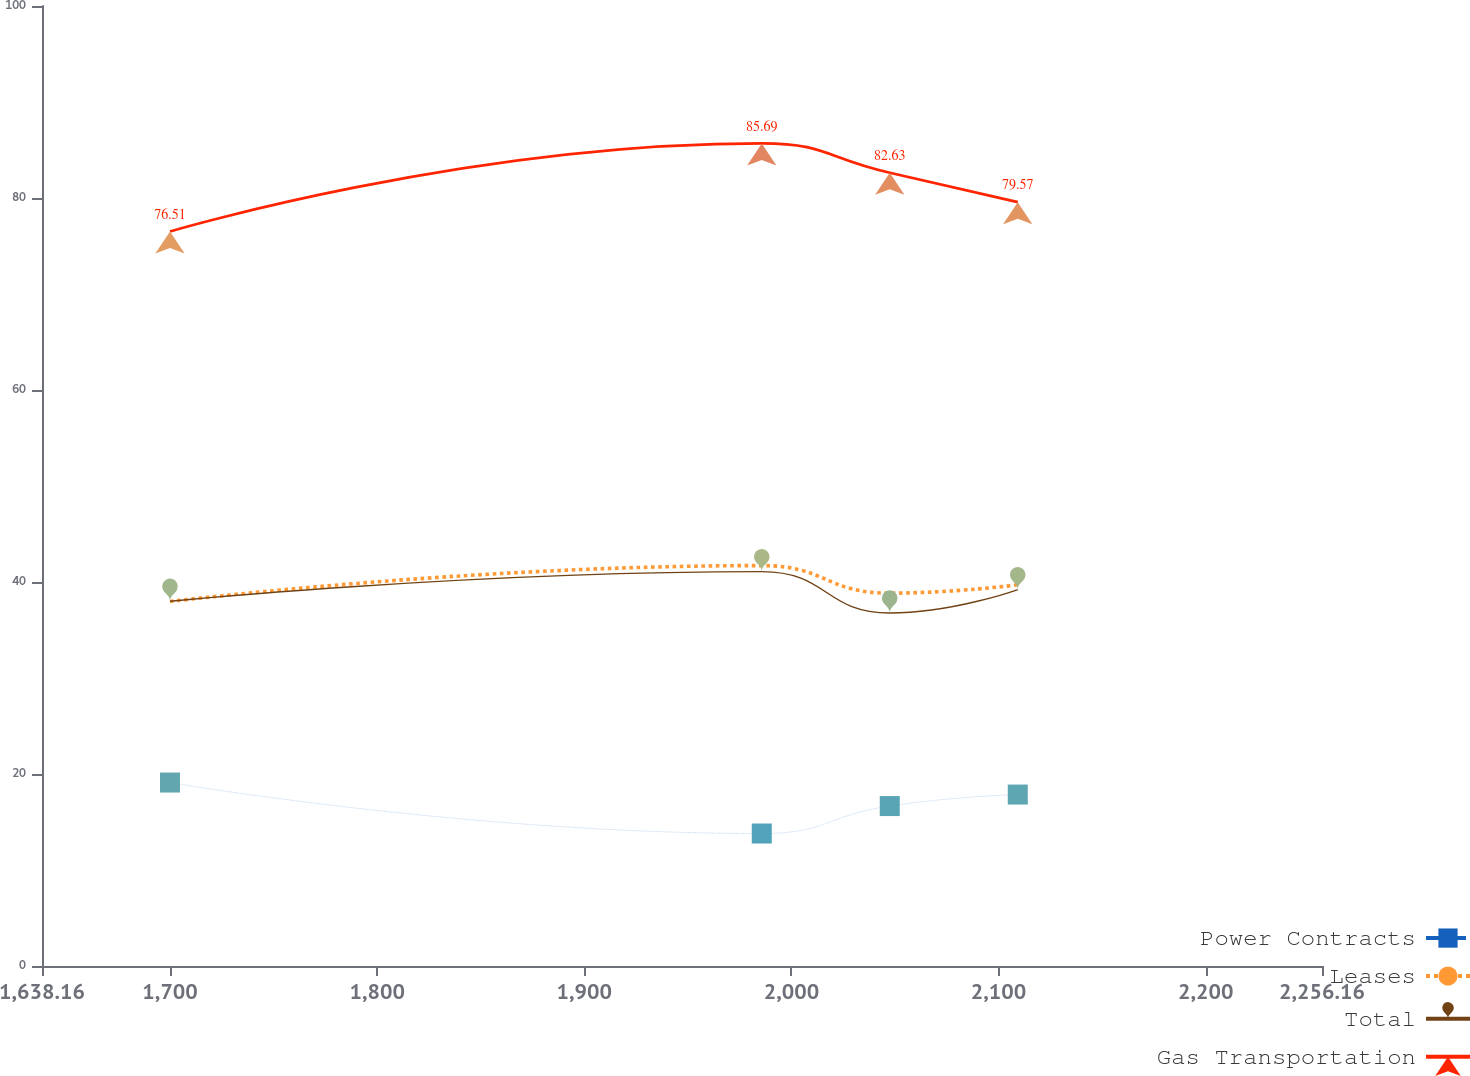Convert chart. <chart><loc_0><loc_0><loc_500><loc_500><line_chart><ecel><fcel>Power Contracts<fcel>Leases<fcel>Total<fcel>Gas Transportation<nl><fcel>1699.96<fcel>19.11<fcel>37.97<fcel>37.99<fcel>76.51<nl><fcel>1985.67<fcel>13.8<fcel>41.71<fcel>41.08<fcel>85.69<nl><fcel>2047.47<fcel>16.66<fcel>38.84<fcel>36.77<fcel>82.63<nl><fcel>2109.27<fcel>17.86<fcel>39.71<fcel>39.21<fcel>79.57<nl><fcel>2317.96<fcel>15.56<fcel>33.03<fcel>28.86<fcel>107.14<nl></chart> 